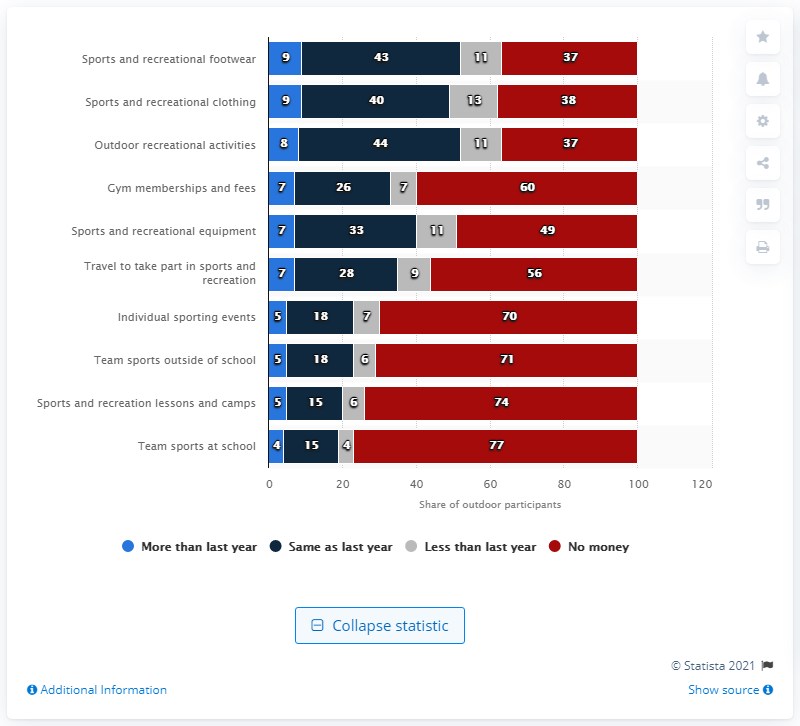Highlight a few significant elements in this photo. According to the survey, 43% of the respondents reported that they spent the same amount of money on sports and recreation clothing as they did in the previous year. 